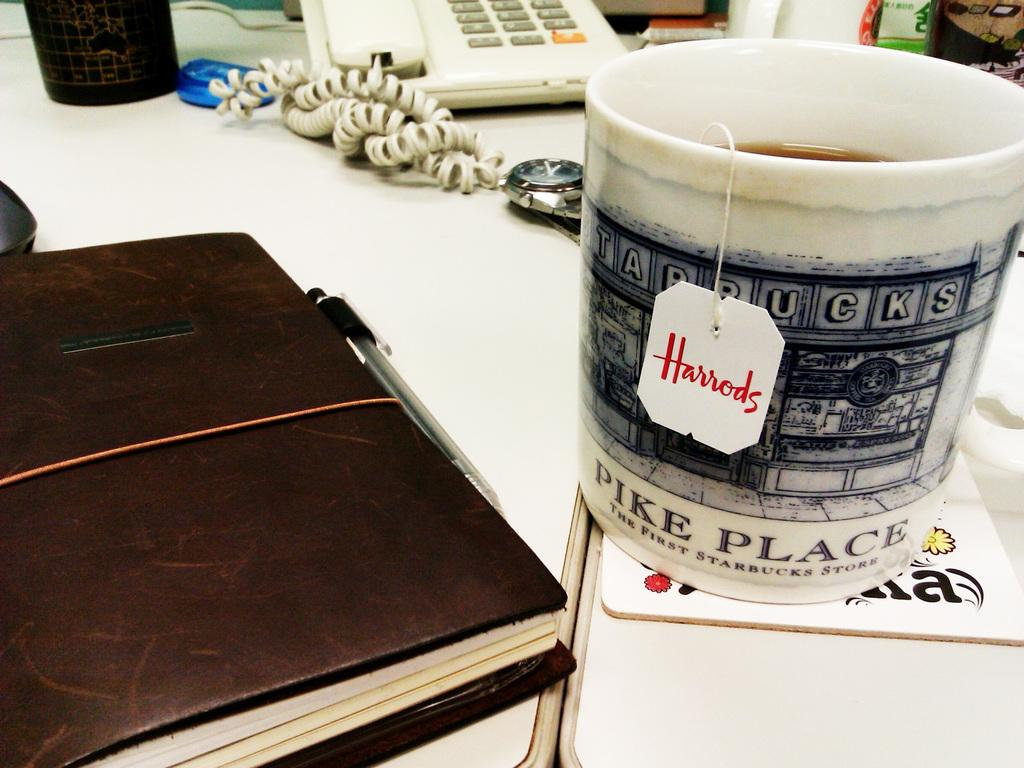<image>
Provide a brief description of the given image. A mug from the Pike Place Starbucks sitting next to a leather bound book on a table. 